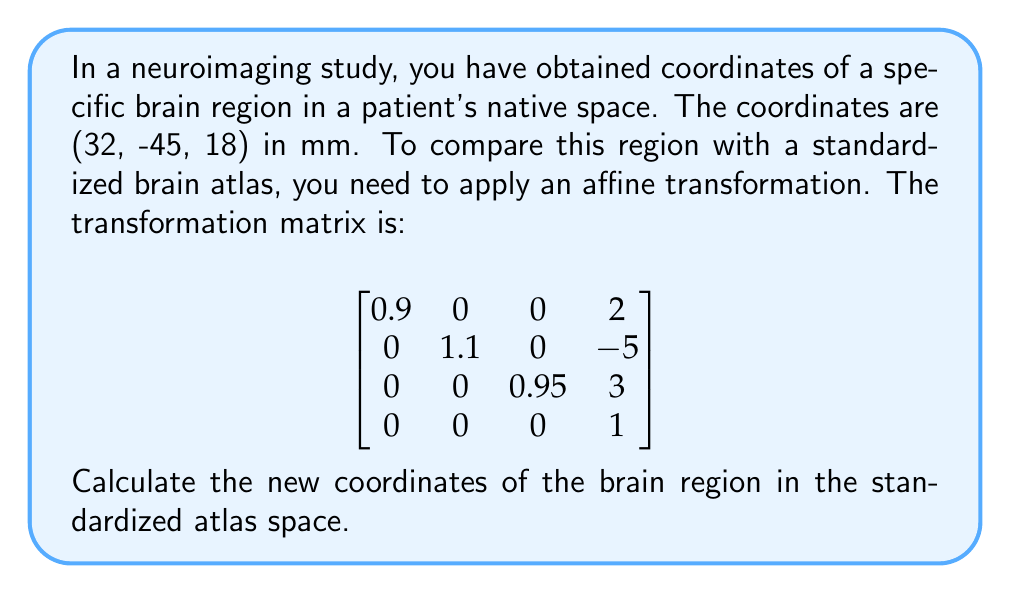Can you solve this math problem? To transform the coordinates from the patient's native space to the standardized atlas space, we need to apply the given affine transformation matrix to the original coordinates. Here's how to do it step-by-step:

1. First, we need to represent the original coordinates as a 4D vector by adding a 1 as the fourth component:

   $\begin{bmatrix} 32 \\ -45 \\ 18 \\ 1 \end{bmatrix}$

2. Now, we multiply the transformation matrix by this vector:

   $$
   \begin{bmatrix}
   0.9 & 0 & 0 & 2 \\
   0 & 1.1 & 0 & -5 \\
   0 & 0 & 0.95 & 3 \\
   0 & 0 & 0 & 1
   \end{bmatrix}
   \times
   \begin{bmatrix} 32 \\ -45 \\ 18 \\ 1 \end{bmatrix}
   $$

3. Let's perform the matrix multiplication:

   - First row: $(0.9 \times 32) + (0 \times -45) + (0 \times 18) + (2 \times 1) = 28.8 + 2 = 30.8$
   - Second row: $(0 \times 32) + (1.1 \times -45) + (0 \times 18) + (-5 \times 1) = -49.5 - 5 = -54.5$
   - Third row: $(0 \times 32) + (0 \times -45) + (0.95 \times 18) + (3 \times 1) = 17.1 + 3 = 20.1$
   - Fourth row: $(0 \times 32) + (0 \times -45) + (0 \times 18) + (1 \times 1) = 1$

4. The resulting vector is:

   $\begin{bmatrix} 30.8 \\ -54.5 \\ 20.1 \\ 1 \end{bmatrix}$

5. We can discard the fourth component (which is always 1 in homogeneous coordinates) to get the final 3D coordinates.

Therefore, the new coordinates in the standardized atlas space are (30.8, -54.5, 20.1) in mm.
Answer: (30.8, -54.5, 20.1) mm 